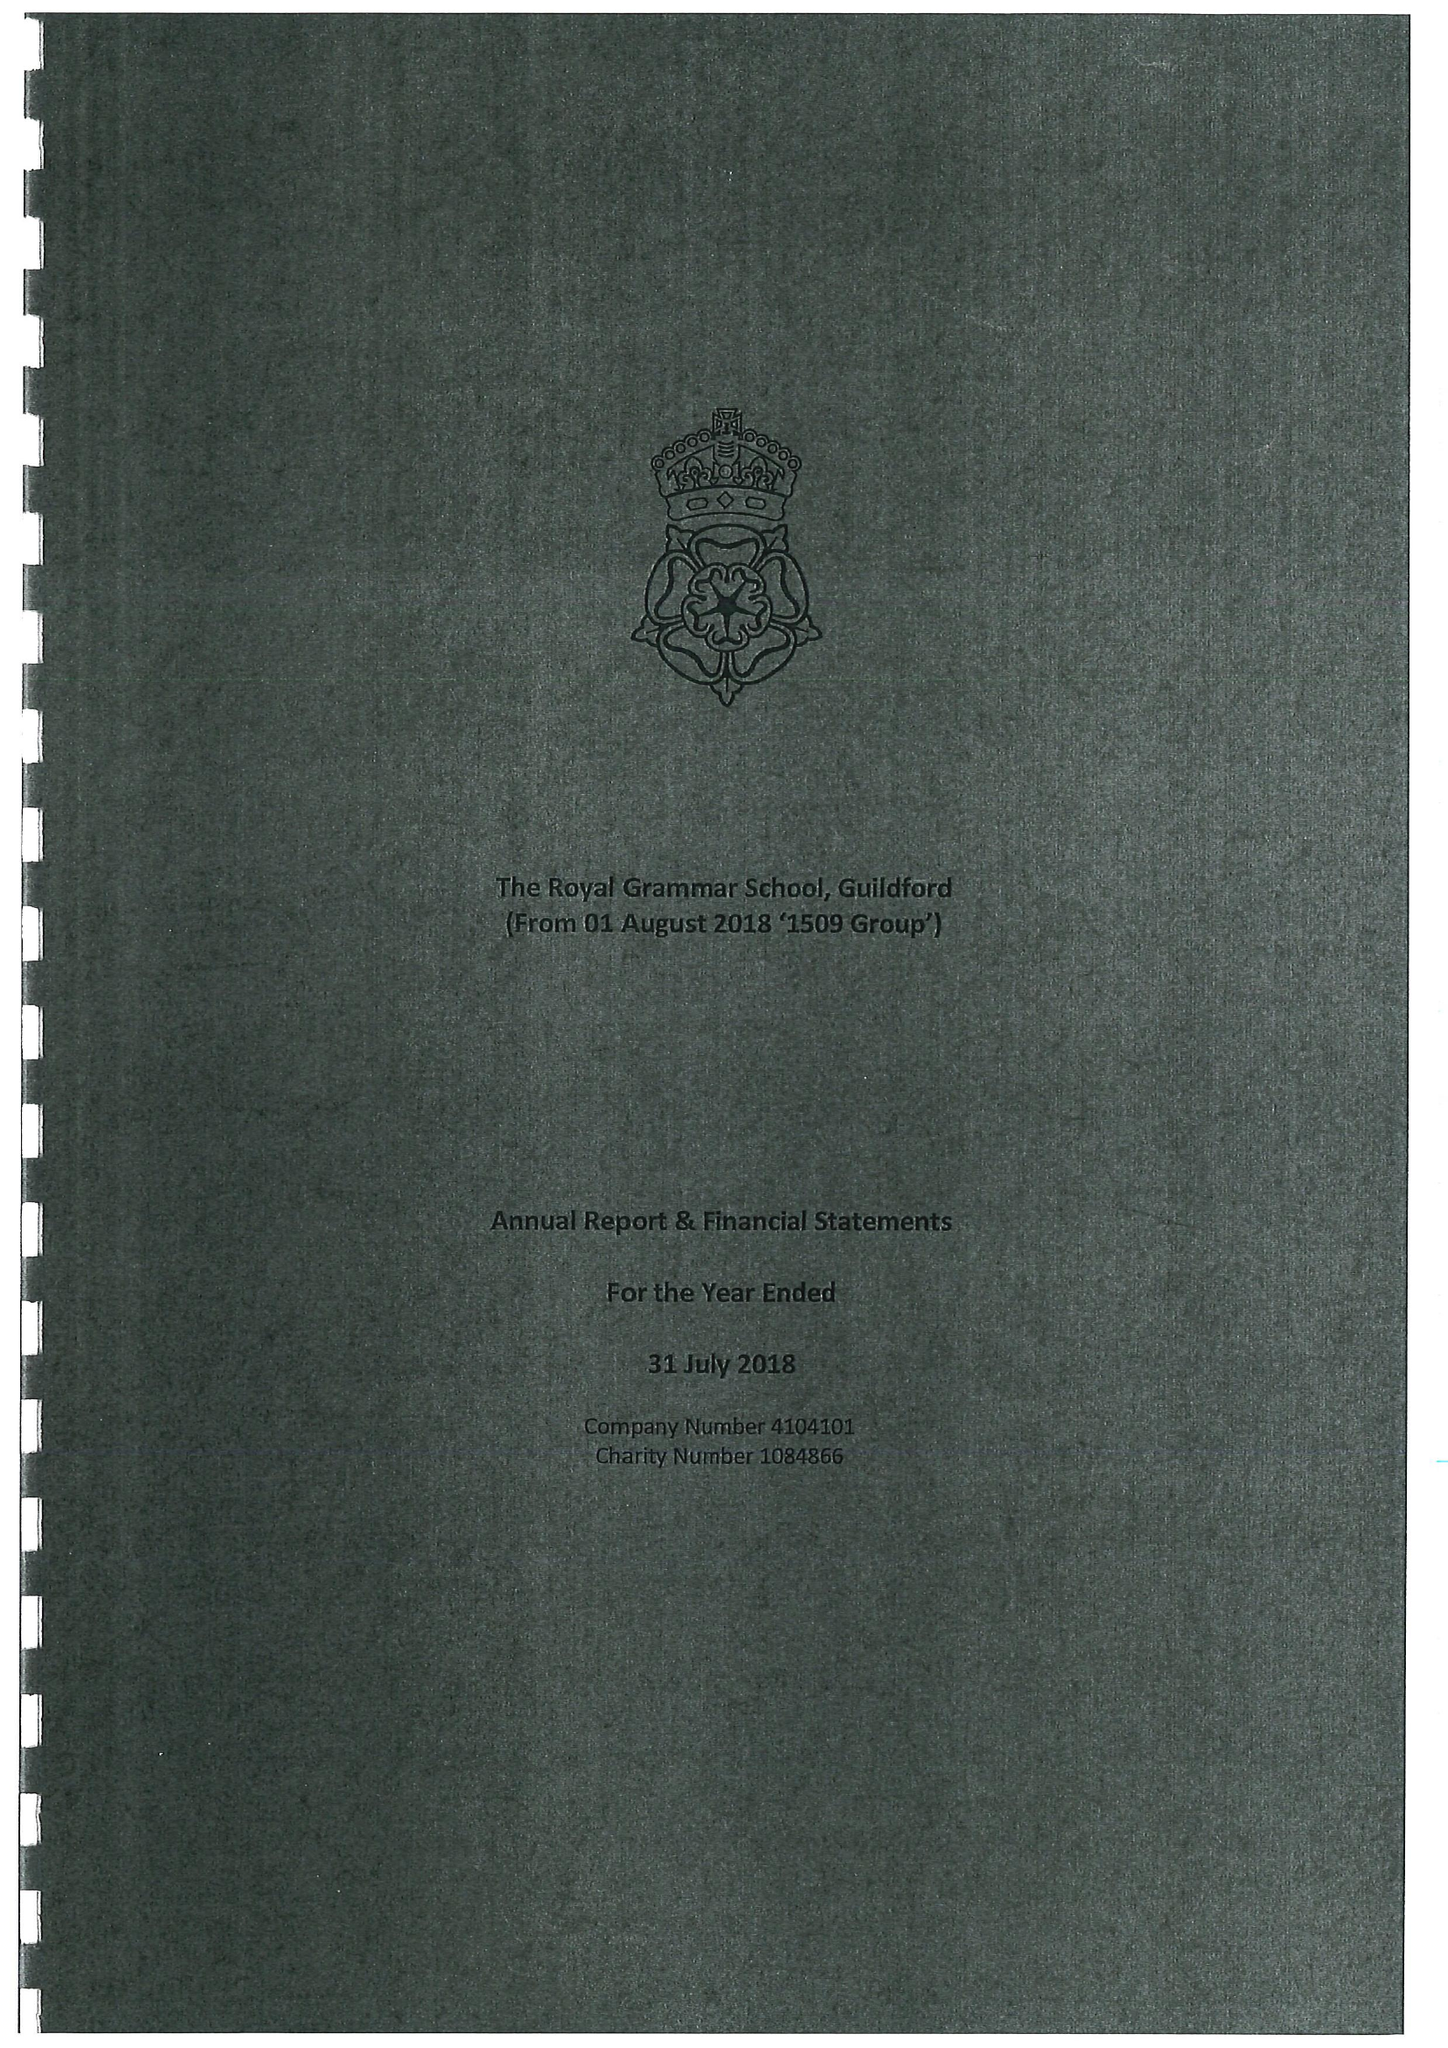What is the value for the spending_annually_in_british_pounds?
Answer the question using a single word or phrase. 21127754.00 